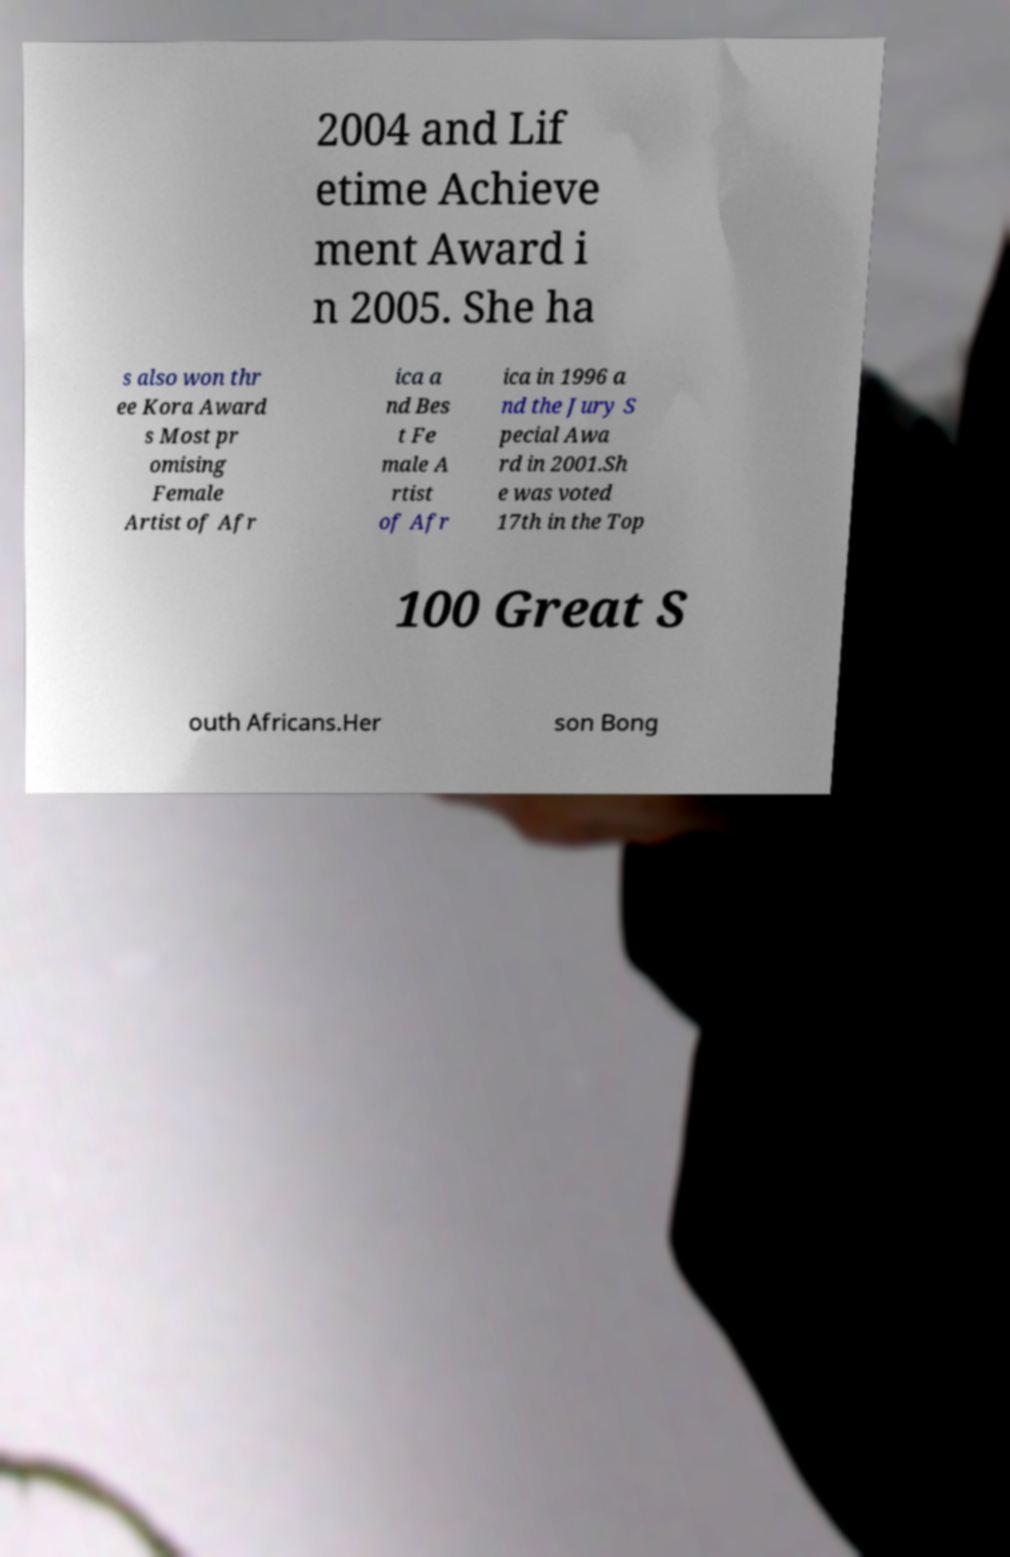There's text embedded in this image that I need extracted. Can you transcribe it verbatim? 2004 and Lif etime Achieve ment Award i n 2005. She ha s also won thr ee Kora Award s Most pr omising Female Artist of Afr ica a nd Bes t Fe male A rtist of Afr ica in 1996 a nd the Jury S pecial Awa rd in 2001.Sh e was voted 17th in the Top 100 Great S outh Africans.Her son Bong 